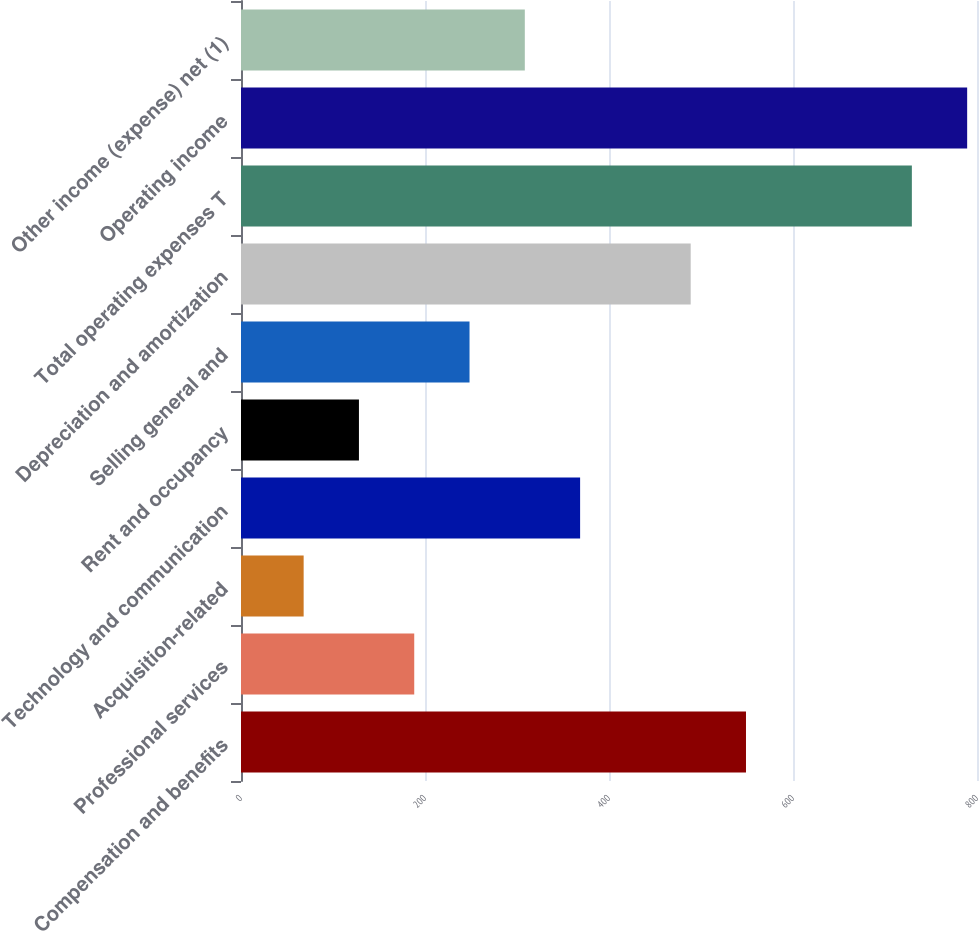<chart> <loc_0><loc_0><loc_500><loc_500><bar_chart><fcel>Compensation and benefits<fcel>Professional services<fcel>Acquisition-related<fcel>Technology and communication<fcel>Rent and occupancy<fcel>Selling general and<fcel>Depreciation and amortization<fcel>Total operating expenses T<fcel>Operating income<fcel>Other income (expense) net (1)<nl><fcel>548.9<fcel>188.3<fcel>68.1<fcel>368.6<fcel>128.2<fcel>248.4<fcel>488.8<fcel>729.2<fcel>789.3<fcel>308.5<nl></chart> 